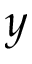<formula> <loc_0><loc_0><loc_500><loc_500>y</formula> 